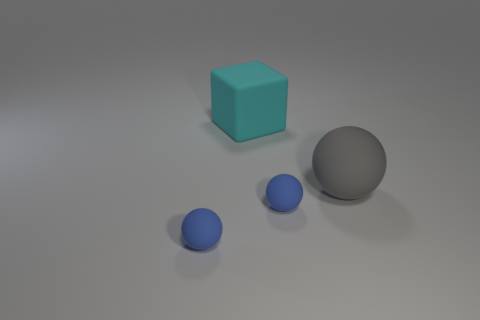Add 1 spheres. How many objects exist? 5 Subtract all cubes. How many objects are left? 3 Subtract 0 gray cylinders. How many objects are left? 4 Subtract all big blocks. Subtract all tiny blue objects. How many objects are left? 1 Add 1 big cyan matte objects. How many big cyan matte objects are left? 2 Add 2 small things. How many small things exist? 4 